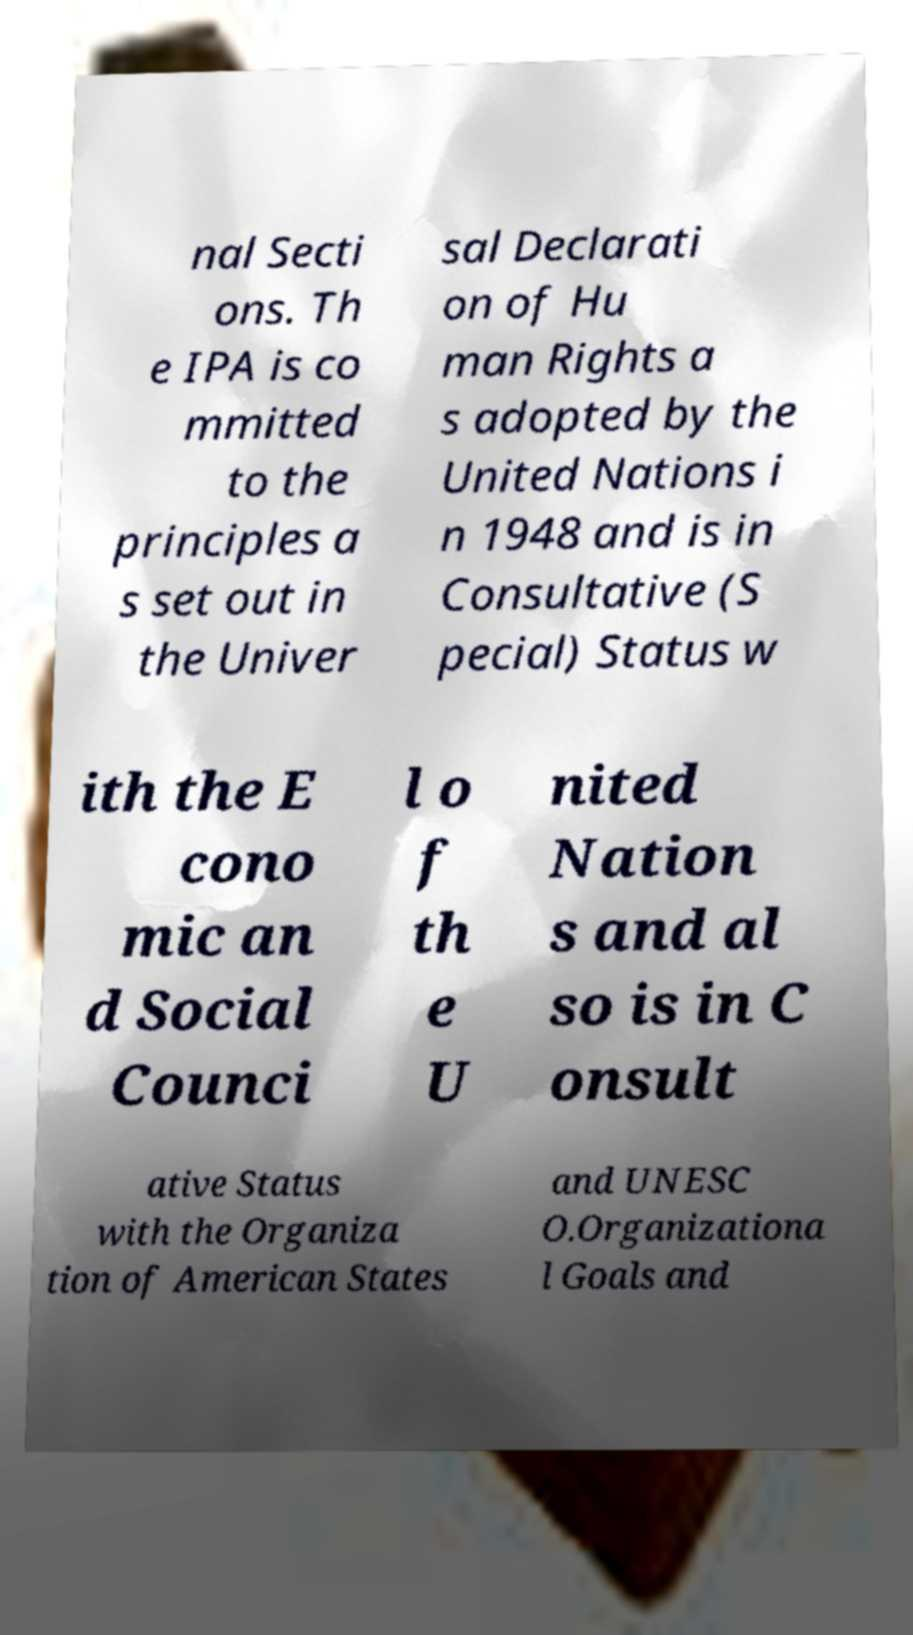Can you read and provide the text displayed in the image?This photo seems to have some interesting text. Can you extract and type it out for me? nal Secti ons. Th e IPA is co mmitted to the principles a s set out in the Univer sal Declarati on of Hu man Rights a s adopted by the United Nations i n 1948 and is in Consultative (S pecial) Status w ith the E cono mic an d Social Counci l o f th e U nited Nation s and al so is in C onsult ative Status with the Organiza tion of American States and UNESC O.Organizationa l Goals and 